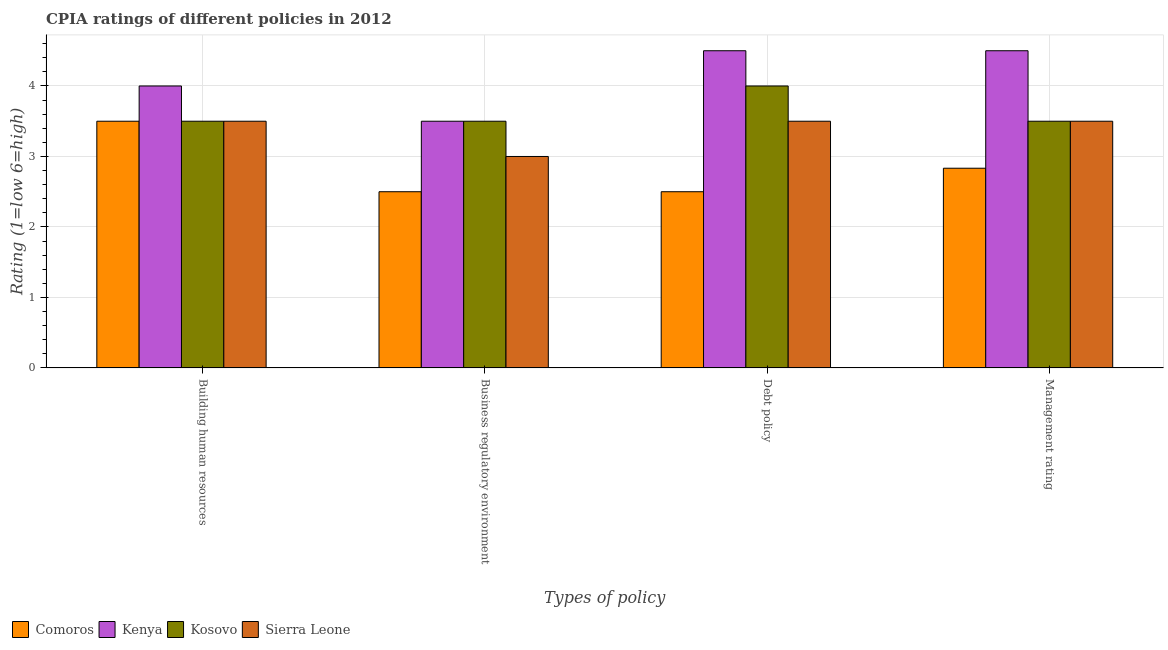How many different coloured bars are there?
Your response must be concise. 4. How many groups of bars are there?
Make the answer very short. 4. What is the label of the 2nd group of bars from the left?
Ensure brevity in your answer.  Business regulatory environment. What is the cpia rating of management in Kenya?
Make the answer very short. 4.5. Across all countries, what is the maximum cpia rating of business regulatory environment?
Keep it short and to the point. 3.5. In which country was the cpia rating of business regulatory environment maximum?
Offer a very short reply. Kenya. In which country was the cpia rating of business regulatory environment minimum?
Keep it short and to the point. Comoros. What is the average cpia rating of debt policy per country?
Keep it short and to the point. 3.62. What is the difference between the cpia rating of business regulatory environment and cpia rating of debt policy in Sierra Leone?
Give a very brief answer. -0.5. Is the cpia rating of debt policy in Kosovo less than that in Kenya?
Your response must be concise. Yes. Is the sum of the cpia rating of business regulatory environment in Sierra Leone and Comoros greater than the maximum cpia rating of management across all countries?
Ensure brevity in your answer.  Yes. What does the 1st bar from the left in Debt policy represents?
Provide a succinct answer. Comoros. What does the 3rd bar from the right in Building human resources represents?
Give a very brief answer. Kenya. How many countries are there in the graph?
Ensure brevity in your answer.  4. What is the difference between two consecutive major ticks on the Y-axis?
Your response must be concise. 1. How many legend labels are there?
Offer a terse response. 4. What is the title of the graph?
Make the answer very short. CPIA ratings of different policies in 2012. Does "Isle of Man" appear as one of the legend labels in the graph?
Your answer should be compact. No. What is the label or title of the X-axis?
Your answer should be compact. Types of policy. What is the label or title of the Y-axis?
Give a very brief answer. Rating (1=low 6=high). What is the Rating (1=low 6=high) in Comoros in Building human resources?
Provide a succinct answer. 3.5. What is the Rating (1=low 6=high) in Kosovo in Building human resources?
Your answer should be very brief. 3.5. What is the Rating (1=low 6=high) of Sierra Leone in Building human resources?
Make the answer very short. 3.5. What is the Rating (1=low 6=high) in Kenya in Business regulatory environment?
Give a very brief answer. 3.5. What is the Rating (1=low 6=high) in Sierra Leone in Business regulatory environment?
Make the answer very short. 3. What is the Rating (1=low 6=high) of Comoros in Debt policy?
Your answer should be very brief. 2.5. What is the Rating (1=low 6=high) in Comoros in Management rating?
Keep it short and to the point. 2.83. What is the Rating (1=low 6=high) of Sierra Leone in Management rating?
Offer a very short reply. 3.5. Across all Types of policy, what is the maximum Rating (1=low 6=high) of Kenya?
Provide a succinct answer. 4.5. Across all Types of policy, what is the maximum Rating (1=low 6=high) in Sierra Leone?
Offer a terse response. 3.5. Across all Types of policy, what is the minimum Rating (1=low 6=high) of Kosovo?
Keep it short and to the point. 3.5. Across all Types of policy, what is the minimum Rating (1=low 6=high) of Sierra Leone?
Your answer should be compact. 3. What is the total Rating (1=low 6=high) of Comoros in the graph?
Your answer should be compact. 11.33. What is the total Rating (1=low 6=high) in Kenya in the graph?
Your answer should be compact. 16.5. What is the total Rating (1=low 6=high) of Sierra Leone in the graph?
Provide a succinct answer. 13.5. What is the difference between the Rating (1=low 6=high) in Comoros in Building human resources and that in Business regulatory environment?
Make the answer very short. 1. What is the difference between the Rating (1=low 6=high) in Kosovo in Building human resources and that in Business regulatory environment?
Keep it short and to the point. 0. What is the difference between the Rating (1=low 6=high) in Comoros in Building human resources and that in Debt policy?
Your answer should be very brief. 1. What is the difference between the Rating (1=low 6=high) of Kenya in Building human resources and that in Debt policy?
Your answer should be very brief. -0.5. What is the difference between the Rating (1=low 6=high) of Kosovo in Building human resources and that in Debt policy?
Your response must be concise. -0.5. What is the difference between the Rating (1=low 6=high) of Kenya in Building human resources and that in Management rating?
Your answer should be very brief. -0.5. What is the difference between the Rating (1=low 6=high) in Sierra Leone in Building human resources and that in Management rating?
Your response must be concise. 0. What is the difference between the Rating (1=low 6=high) in Kenya in Business regulatory environment and that in Debt policy?
Ensure brevity in your answer.  -1. What is the difference between the Rating (1=low 6=high) in Sierra Leone in Business regulatory environment and that in Debt policy?
Your answer should be compact. -0.5. What is the difference between the Rating (1=low 6=high) in Kosovo in Business regulatory environment and that in Management rating?
Keep it short and to the point. 0. What is the difference between the Rating (1=low 6=high) in Sierra Leone in Business regulatory environment and that in Management rating?
Keep it short and to the point. -0.5. What is the difference between the Rating (1=low 6=high) of Comoros in Debt policy and that in Management rating?
Give a very brief answer. -0.33. What is the difference between the Rating (1=low 6=high) in Kenya in Debt policy and that in Management rating?
Provide a succinct answer. 0. What is the difference between the Rating (1=low 6=high) in Sierra Leone in Debt policy and that in Management rating?
Offer a terse response. 0. What is the difference between the Rating (1=low 6=high) in Comoros in Building human resources and the Rating (1=low 6=high) in Sierra Leone in Business regulatory environment?
Provide a succinct answer. 0.5. What is the difference between the Rating (1=low 6=high) in Comoros in Building human resources and the Rating (1=low 6=high) in Kosovo in Debt policy?
Ensure brevity in your answer.  -0.5. What is the difference between the Rating (1=low 6=high) in Kenya in Building human resources and the Rating (1=low 6=high) in Kosovo in Debt policy?
Your answer should be very brief. 0. What is the difference between the Rating (1=low 6=high) in Kenya in Building human resources and the Rating (1=low 6=high) in Sierra Leone in Debt policy?
Provide a succinct answer. 0.5. What is the difference between the Rating (1=low 6=high) in Comoros in Building human resources and the Rating (1=low 6=high) in Sierra Leone in Management rating?
Give a very brief answer. 0. What is the difference between the Rating (1=low 6=high) in Comoros in Business regulatory environment and the Rating (1=low 6=high) in Kenya in Debt policy?
Provide a short and direct response. -2. What is the difference between the Rating (1=low 6=high) in Comoros in Business regulatory environment and the Rating (1=low 6=high) in Kosovo in Debt policy?
Your answer should be very brief. -1.5. What is the difference between the Rating (1=low 6=high) of Comoros in Business regulatory environment and the Rating (1=low 6=high) of Sierra Leone in Debt policy?
Ensure brevity in your answer.  -1. What is the difference between the Rating (1=low 6=high) in Comoros in Business regulatory environment and the Rating (1=low 6=high) in Kosovo in Management rating?
Provide a succinct answer. -1. What is the difference between the Rating (1=low 6=high) of Comoros in Business regulatory environment and the Rating (1=low 6=high) of Sierra Leone in Management rating?
Your answer should be compact. -1. What is the difference between the Rating (1=low 6=high) of Kenya in Business regulatory environment and the Rating (1=low 6=high) of Kosovo in Management rating?
Keep it short and to the point. 0. What is the difference between the Rating (1=low 6=high) in Kosovo in Business regulatory environment and the Rating (1=low 6=high) in Sierra Leone in Management rating?
Provide a short and direct response. 0. What is the difference between the Rating (1=low 6=high) in Kenya in Debt policy and the Rating (1=low 6=high) in Sierra Leone in Management rating?
Your response must be concise. 1. What is the difference between the Rating (1=low 6=high) of Kosovo in Debt policy and the Rating (1=low 6=high) of Sierra Leone in Management rating?
Provide a succinct answer. 0.5. What is the average Rating (1=low 6=high) of Comoros per Types of policy?
Provide a succinct answer. 2.83. What is the average Rating (1=low 6=high) in Kenya per Types of policy?
Keep it short and to the point. 4.12. What is the average Rating (1=low 6=high) of Kosovo per Types of policy?
Provide a short and direct response. 3.62. What is the average Rating (1=low 6=high) of Sierra Leone per Types of policy?
Your response must be concise. 3.38. What is the difference between the Rating (1=low 6=high) in Comoros and Rating (1=low 6=high) in Kenya in Building human resources?
Your answer should be compact. -0.5. What is the difference between the Rating (1=low 6=high) of Comoros and Rating (1=low 6=high) of Kosovo in Building human resources?
Offer a terse response. 0. What is the difference between the Rating (1=low 6=high) of Kenya and Rating (1=low 6=high) of Sierra Leone in Building human resources?
Offer a terse response. 0.5. What is the difference between the Rating (1=low 6=high) in Kosovo and Rating (1=low 6=high) in Sierra Leone in Building human resources?
Offer a terse response. 0. What is the difference between the Rating (1=low 6=high) in Comoros and Rating (1=low 6=high) in Sierra Leone in Business regulatory environment?
Offer a very short reply. -0.5. What is the difference between the Rating (1=low 6=high) of Kenya and Rating (1=low 6=high) of Sierra Leone in Business regulatory environment?
Offer a very short reply. 0.5. What is the difference between the Rating (1=low 6=high) in Kosovo and Rating (1=low 6=high) in Sierra Leone in Business regulatory environment?
Make the answer very short. 0.5. What is the difference between the Rating (1=low 6=high) in Comoros and Rating (1=low 6=high) in Kosovo in Debt policy?
Provide a succinct answer. -1.5. What is the difference between the Rating (1=low 6=high) of Kenya and Rating (1=low 6=high) of Kosovo in Debt policy?
Provide a short and direct response. 0.5. What is the difference between the Rating (1=low 6=high) of Comoros and Rating (1=low 6=high) of Kenya in Management rating?
Offer a very short reply. -1.67. What is the difference between the Rating (1=low 6=high) in Comoros and Rating (1=low 6=high) in Sierra Leone in Management rating?
Your answer should be very brief. -0.67. What is the difference between the Rating (1=low 6=high) of Kenya and Rating (1=low 6=high) of Sierra Leone in Management rating?
Your answer should be compact. 1. What is the difference between the Rating (1=low 6=high) of Kosovo and Rating (1=low 6=high) of Sierra Leone in Management rating?
Your answer should be very brief. 0. What is the ratio of the Rating (1=low 6=high) in Kenya in Building human resources to that in Business regulatory environment?
Your response must be concise. 1.14. What is the ratio of the Rating (1=low 6=high) in Sierra Leone in Building human resources to that in Business regulatory environment?
Ensure brevity in your answer.  1.17. What is the ratio of the Rating (1=low 6=high) of Comoros in Building human resources to that in Debt policy?
Provide a short and direct response. 1.4. What is the ratio of the Rating (1=low 6=high) of Kenya in Building human resources to that in Debt policy?
Your answer should be very brief. 0.89. What is the ratio of the Rating (1=low 6=high) of Comoros in Building human resources to that in Management rating?
Your response must be concise. 1.24. What is the ratio of the Rating (1=low 6=high) in Kosovo in Building human resources to that in Management rating?
Offer a very short reply. 1. What is the ratio of the Rating (1=low 6=high) of Comoros in Business regulatory environment to that in Debt policy?
Your response must be concise. 1. What is the ratio of the Rating (1=low 6=high) of Kenya in Business regulatory environment to that in Debt policy?
Provide a succinct answer. 0.78. What is the ratio of the Rating (1=low 6=high) in Sierra Leone in Business regulatory environment to that in Debt policy?
Your response must be concise. 0.86. What is the ratio of the Rating (1=low 6=high) of Comoros in Business regulatory environment to that in Management rating?
Your answer should be compact. 0.88. What is the ratio of the Rating (1=low 6=high) in Kenya in Business regulatory environment to that in Management rating?
Keep it short and to the point. 0.78. What is the ratio of the Rating (1=low 6=high) in Sierra Leone in Business regulatory environment to that in Management rating?
Keep it short and to the point. 0.86. What is the ratio of the Rating (1=low 6=high) in Comoros in Debt policy to that in Management rating?
Your answer should be very brief. 0.88. What is the ratio of the Rating (1=low 6=high) of Kenya in Debt policy to that in Management rating?
Ensure brevity in your answer.  1. What is the ratio of the Rating (1=low 6=high) in Kosovo in Debt policy to that in Management rating?
Keep it short and to the point. 1.14. What is the difference between the highest and the second highest Rating (1=low 6=high) in Comoros?
Keep it short and to the point. 0.67. What is the difference between the highest and the second highest Rating (1=low 6=high) of Kenya?
Your answer should be compact. 0. What is the difference between the highest and the second highest Rating (1=low 6=high) of Kosovo?
Provide a short and direct response. 0.5. What is the difference between the highest and the lowest Rating (1=low 6=high) in Comoros?
Ensure brevity in your answer.  1. What is the difference between the highest and the lowest Rating (1=low 6=high) in Kosovo?
Keep it short and to the point. 0.5. 